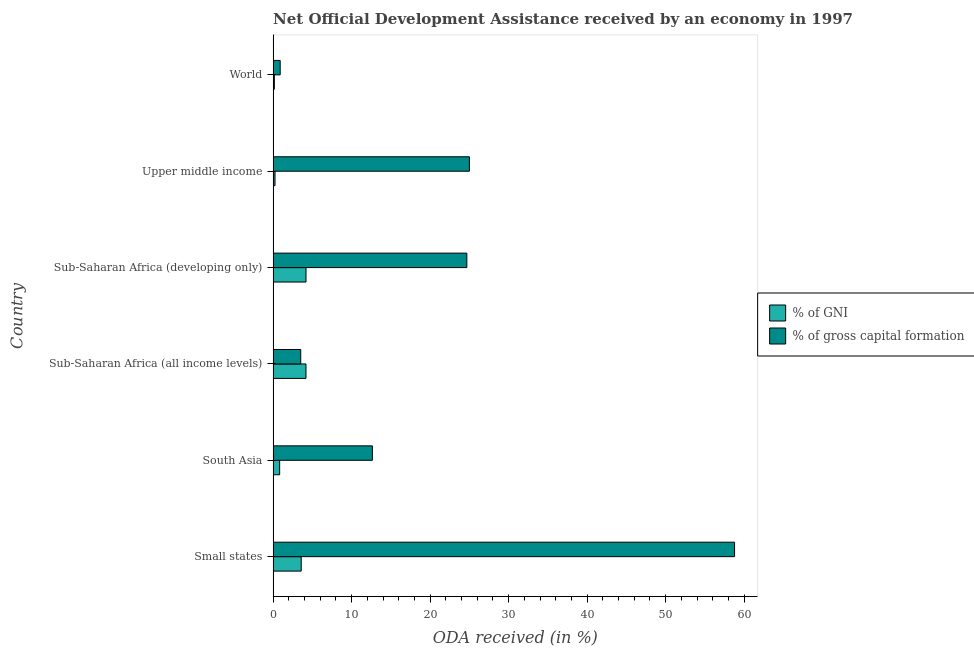How many groups of bars are there?
Offer a very short reply. 6. How many bars are there on the 1st tick from the top?
Your answer should be compact. 2. How many bars are there on the 5th tick from the bottom?
Offer a terse response. 2. What is the oda received as percentage of gross capital formation in Sub-Saharan Africa (developing only)?
Give a very brief answer. 24.67. Across all countries, what is the maximum oda received as percentage of gni?
Make the answer very short. 4.19. Across all countries, what is the minimum oda received as percentage of gross capital formation?
Provide a succinct answer. 0.9. In which country was the oda received as percentage of gross capital formation maximum?
Your response must be concise. Small states. What is the total oda received as percentage of gross capital formation in the graph?
Provide a short and direct response. 125.51. What is the difference between the oda received as percentage of gni in Small states and that in Sub-Saharan Africa (all income levels)?
Your answer should be very brief. -0.6. What is the difference between the oda received as percentage of gross capital formation in South Asia and the oda received as percentage of gni in Sub-Saharan Africa (developing only)?
Give a very brief answer. 8.46. What is the average oda received as percentage of gross capital formation per country?
Ensure brevity in your answer.  20.92. What is the difference between the oda received as percentage of gross capital formation and oda received as percentage of gni in South Asia?
Provide a short and direct response. 11.81. In how many countries, is the oda received as percentage of gross capital formation greater than 40 %?
Keep it short and to the point. 1. What is the ratio of the oda received as percentage of gni in Sub-Saharan Africa (all income levels) to that in Upper middle income?
Ensure brevity in your answer.  17.27. What is the difference between the highest and the second highest oda received as percentage of gross capital formation?
Keep it short and to the point. 33.78. What is the difference between the highest and the lowest oda received as percentage of gross capital formation?
Your answer should be compact. 57.88. In how many countries, is the oda received as percentage of gni greater than the average oda received as percentage of gni taken over all countries?
Provide a short and direct response. 3. Is the sum of the oda received as percentage of gross capital formation in Small states and Upper middle income greater than the maximum oda received as percentage of gni across all countries?
Offer a terse response. Yes. What does the 1st bar from the top in South Asia represents?
Your answer should be very brief. % of gross capital formation. What does the 1st bar from the bottom in Small states represents?
Your answer should be compact. % of GNI. How many bars are there?
Offer a terse response. 12. Are all the bars in the graph horizontal?
Ensure brevity in your answer.  Yes. What is the difference between two consecutive major ticks on the X-axis?
Make the answer very short. 10. Does the graph contain any zero values?
Give a very brief answer. No. Does the graph contain grids?
Your answer should be very brief. No. What is the title of the graph?
Make the answer very short. Net Official Development Assistance received by an economy in 1997. What is the label or title of the X-axis?
Offer a very short reply. ODA received (in %). What is the label or title of the Y-axis?
Keep it short and to the point. Country. What is the ODA received (in %) of % of GNI in Small states?
Offer a terse response. 3.58. What is the ODA received (in %) in % of gross capital formation in Small states?
Offer a terse response. 58.78. What is the ODA received (in %) of % of GNI in South Asia?
Provide a short and direct response. 0.83. What is the ODA received (in %) of % of gross capital formation in South Asia?
Your answer should be very brief. 12.64. What is the ODA received (in %) of % of GNI in Sub-Saharan Africa (all income levels)?
Provide a short and direct response. 4.18. What is the ODA received (in %) of % of gross capital formation in Sub-Saharan Africa (all income levels)?
Give a very brief answer. 3.52. What is the ODA received (in %) in % of GNI in Sub-Saharan Africa (developing only)?
Keep it short and to the point. 4.19. What is the ODA received (in %) of % of gross capital formation in Sub-Saharan Africa (developing only)?
Provide a succinct answer. 24.67. What is the ODA received (in %) in % of GNI in Upper middle income?
Offer a very short reply. 0.24. What is the ODA received (in %) of % of gross capital formation in Upper middle income?
Ensure brevity in your answer.  25. What is the ODA received (in %) in % of GNI in World?
Your answer should be very brief. 0.16. What is the ODA received (in %) of % of gross capital formation in World?
Keep it short and to the point. 0.9. Across all countries, what is the maximum ODA received (in %) in % of GNI?
Make the answer very short. 4.19. Across all countries, what is the maximum ODA received (in %) in % of gross capital formation?
Offer a very short reply. 58.78. Across all countries, what is the minimum ODA received (in %) of % of GNI?
Your answer should be compact. 0.16. Across all countries, what is the minimum ODA received (in %) in % of gross capital formation?
Your answer should be compact. 0.9. What is the total ODA received (in %) of % of GNI in the graph?
Ensure brevity in your answer.  13.18. What is the total ODA received (in %) in % of gross capital formation in the graph?
Ensure brevity in your answer.  125.52. What is the difference between the ODA received (in %) in % of GNI in Small states and that in South Asia?
Ensure brevity in your answer.  2.75. What is the difference between the ODA received (in %) in % of gross capital formation in Small states and that in South Asia?
Your response must be concise. 46.13. What is the difference between the ODA received (in %) of % of GNI in Small states and that in Sub-Saharan Africa (all income levels)?
Offer a very short reply. -0.6. What is the difference between the ODA received (in %) of % of gross capital formation in Small states and that in Sub-Saharan Africa (all income levels)?
Provide a succinct answer. 55.26. What is the difference between the ODA received (in %) in % of GNI in Small states and that in Sub-Saharan Africa (developing only)?
Offer a terse response. -0.61. What is the difference between the ODA received (in %) of % of gross capital formation in Small states and that in Sub-Saharan Africa (developing only)?
Offer a very short reply. 34.1. What is the difference between the ODA received (in %) of % of GNI in Small states and that in Upper middle income?
Provide a short and direct response. 3.34. What is the difference between the ODA received (in %) in % of gross capital formation in Small states and that in Upper middle income?
Make the answer very short. 33.78. What is the difference between the ODA received (in %) of % of GNI in Small states and that in World?
Your response must be concise. 3.42. What is the difference between the ODA received (in %) of % of gross capital formation in Small states and that in World?
Offer a very short reply. 57.88. What is the difference between the ODA received (in %) in % of GNI in South Asia and that in Sub-Saharan Africa (all income levels)?
Your response must be concise. -3.35. What is the difference between the ODA received (in %) of % of gross capital formation in South Asia and that in Sub-Saharan Africa (all income levels)?
Make the answer very short. 9.13. What is the difference between the ODA received (in %) of % of GNI in South Asia and that in Sub-Saharan Africa (developing only)?
Give a very brief answer. -3.36. What is the difference between the ODA received (in %) of % of gross capital formation in South Asia and that in Sub-Saharan Africa (developing only)?
Your response must be concise. -12.03. What is the difference between the ODA received (in %) in % of GNI in South Asia and that in Upper middle income?
Give a very brief answer. 0.59. What is the difference between the ODA received (in %) in % of gross capital formation in South Asia and that in Upper middle income?
Offer a terse response. -12.36. What is the difference between the ODA received (in %) of % of GNI in South Asia and that in World?
Keep it short and to the point. 0.67. What is the difference between the ODA received (in %) of % of gross capital formation in South Asia and that in World?
Your answer should be very brief. 11.74. What is the difference between the ODA received (in %) of % of GNI in Sub-Saharan Africa (all income levels) and that in Sub-Saharan Africa (developing only)?
Provide a short and direct response. -0. What is the difference between the ODA received (in %) of % of gross capital formation in Sub-Saharan Africa (all income levels) and that in Sub-Saharan Africa (developing only)?
Your response must be concise. -21.16. What is the difference between the ODA received (in %) of % of GNI in Sub-Saharan Africa (all income levels) and that in Upper middle income?
Make the answer very short. 3.94. What is the difference between the ODA received (in %) of % of gross capital formation in Sub-Saharan Africa (all income levels) and that in Upper middle income?
Provide a succinct answer. -21.49. What is the difference between the ODA received (in %) of % of GNI in Sub-Saharan Africa (all income levels) and that in World?
Your response must be concise. 4.03. What is the difference between the ODA received (in %) of % of gross capital formation in Sub-Saharan Africa (all income levels) and that in World?
Your response must be concise. 2.62. What is the difference between the ODA received (in %) in % of GNI in Sub-Saharan Africa (developing only) and that in Upper middle income?
Your answer should be very brief. 3.95. What is the difference between the ODA received (in %) of % of gross capital formation in Sub-Saharan Africa (developing only) and that in Upper middle income?
Offer a terse response. -0.33. What is the difference between the ODA received (in %) of % of GNI in Sub-Saharan Africa (developing only) and that in World?
Offer a very short reply. 4.03. What is the difference between the ODA received (in %) in % of gross capital formation in Sub-Saharan Africa (developing only) and that in World?
Provide a short and direct response. 23.77. What is the difference between the ODA received (in %) in % of GNI in Upper middle income and that in World?
Provide a short and direct response. 0.09. What is the difference between the ODA received (in %) in % of gross capital formation in Upper middle income and that in World?
Your answer should be compact. 24.1. What is the difference between the ODA received (in %) of % of GNI in Small states and the ODA received (in %) of % of gross capital formation in South Asia?
Your response must be concise. -9.06. What is the difference between the ODA received (in %) of % of GNI in Small states and the ODA received (in %) of % of gross capital formation in Sub-Saharan Africa (all income levels)?
Offer a very short reply. 0.06. What is the difference between the ODA received (in %) of % of GNI in Small states and the ODA received (in %) of % of gross capital formation in Sub-Saharan Africa (developing only)?
Offer a terse response. -21.09. What is the difference between the ODA received (in %) of % of GNI in Small states and the ODA received (in %) of % of gross capital formation in Upper middle income?
Offer a very short reply. -21.42. What is the difference between the ODA received (in %) of % of GNI in Small states and the ODA received (in %) of % of gross capital formation in World?
Offer a very short reply. 2.68. What is the difference between the ODA received (in %) in % of GNI in South Asia and the ODA received (in %) in % of gross capital formation in Sub-Saharan Africa (all income levels)?
Provide a short and direct response. -2.68. What is the difference between the ODA received (in %) in % of GNI in South Asia and the ODA received (in %) in % of gross capital formation in Sub-Saharan Africa (developing only)?
Offer a very short reply. -23.84. What is the difference between the ODA received (in %) of % of GNI in South Asia and the ODA received (in %) of % of gross capital formation in Upper middle income?
Your response must be concise. -24.17. What is the difference between the ODA received (in %) in % of GNI in South Asia and the ODA received (in %) in % of gross capital formation in World?
Offer a terse response. -0.07. What is the difference between the ODA received (in %) of % of GNI in Sub-Saharan Africa (all income levels) and the ODA received (in %) of % of gross capital formation in Sub-Saharan Africa (developing only)?
Keep it short and to the point. -20.49. What is the difference between the ODA received (in %) in % of GNI in Sub-Saharan Africa (all income levels) and the ODA received (in %) in % of gross capital formation in Upper middle income?
Offer a very short reply. -20.82. What is the difference between the ODA received (in %) in % of GNI in Sub-Saharan Africa (all income levels) and the ODA received (in %) in % of gross capital formation in World?
Provide a short and direct response. 3.28. What is the difference between the ODA received (in %) in % of GNI in Sub-Saharan Africa (developing only) and the ODA received (in %) in % of gross capital formation in Upper middle income?
Your answer should be compact. -20.82. What is the difference between the ODA received (in %) in % of GNI in Sub-Saharan Africa (developing only) and the ODA received (in %) in % of gross capital formation in World?
Your response must be concise. 3.29. What is the difference between the ODA received (in %) of % of GNI in Upper middle income and the ODA received (in %) of % of gross capital formation in World?
Ensure brevity in your answer.  -0.66. What is the average ODA received (in %) in % of GNI per country?
Your answer should be very brief. 2.2. What is the average ODA received (in %) in % of gross capital formation per country?
Your answer should be very brief. 20.92. What is the difference between the ODA received (in %) of % of GNI and ODA received (in %) of % of gross capital formation in Small states?
Your response must be concise. -55.2. What is the difference between the ODA received (in %) in % of GNI and ODA received (in %) in % of gross capital formation in South Asia?
Offer a terse response. -11.81. What is the difference between the ODA received (in %) in % of GNI and ODA received (in %) in % of gross capital formation in Sub-Saharan Africa (all income levels)?
Make the answer very short. 0.67. What is the difference between the ODA received (in %) of % of GNI and ODA received (in %) of % of gross capital formation in Sub-Saharan Africa (developing only)?
Ensure brevity in your answer.  -20.49. What is the difference between the ODA received (in %) in % of GNI and ODA received (in %) in % of gross capital formation in Upper middle income?
Your answer should be compact. -24.76. What is the difference between the ODA received (in %) in % of GNI and ODA received (in %) in % of gross capital formation in World?
Provide a short and direct response. -0.74. What is the ratio of the ODA received (in %) of % of GNI in Small states to that in South Asia?
Provide a short and direct response. 4.3. What is the ratio of the ODA received (in %) of % of gross capital formation in Small states to that in South Asia?
Your response must be concise. 4.65. What is the ratio of the ODA received (in %) of % of GNI in Small states to that in Sub-Saharan Africa (all income levels)?
Offer a terse response. 0.86. What is the ratio of the ODA received (in %) of % of gross capital formation in Small states to that in Sub-Saharan Africa (all income levels)?
Offer a very short reply. 16.71. What is the ratio of the ODA received (in %) in % of GNI in Small states to that in Sub-Saharan Africa (developing only)?
Make the answer very short. 0.85. What is the ratio of the ODA received (in %) in % of gross capital formation in Small states to that in Sub-Saharan Africa (developing only)?
Your answer should be very brief. 2.38. What is the ratio of the ODA received (in %) of % of GNI in Small states to that in Upper middle income?
Ensure brevity in your answer.  14.78. What is the ratio of the ODA received (in %) in % of gross capital formation in Small states to that in Upper middle income?
Your response must be concise. 2.35. What is the ratio of the ODA received (in %) of % of GNI in Small states to that in World?
Give a very brief answer. 22.77. What is the ratio of the ODA received (in %) of % of gross capital formation in Small states to that in World?
Ensure brevity in your answer.  65.37. What is the ratio of the ODA received (in %) in % of GNI in South Asia to that in Sub-Saharan Africa (all income levels)?
Your answer should be compact. 0.2. What is the ratio of the ODA received (in %) in % of gross capital formation in South Asia to that in Sub-Saharan Africa (all income levels)?
Give a very brief answer. 3.6. What is the ratio of the ODA received (in %) of % of GNI in South Asia to that in Sub-Saharan Africa (developing only)?
Give a very brief answer. 0.2. What is the ratio of the ODA received (in %) in % of gross capital formation in South Asia to that in Sub-Saharan Africa (developing only)?
Provide a short and direct response. 0.51. What is the ratio of the ODA received (in %) in % of GNI in South Asia to that in Upper middle income?
Give a very brief answer. 3.43. What is the ratio of the ODA received (in %) of % of gross capital formation in South Asia to that in Upper middle income?
Keep it short and to the point. 0.51. What is the ratio of the ODA received (in %) of % of GNI in South Asia to that in World?
Keep it short and to the point. 5.29. What is the ratio of the ODA received (in %) in % of gross capital formation in South Asia to that in World?
Your answer should be compact. 14.06. What is the ratio of the ODA received (in %) of % of GNI in Sub-Saharan Africa (all income levels) to that in Sub-Saharan Africa (developing only)?
Your response must be concise. 1. What is the ratio of the ODA received (in %) in % of gross capital formation in Sub-Saharan Africa (all income levels) to that in Sub-Saharan Africa (developing only)?
Offer a very short reply. 0.14. What is the ratio of the ODA received (in %) of % of GNI in Sub-Saharan Africa (all income levels) to that in Upper middle income?
Give a very brief answer. 17.27. What is the ratio of the ODA received (in %) in % of gross capital formation in Sub-Saharan Africa (all income levels) to that in Upper middle income?
Your answer should be very brief. 0.14. What is the ratio of the ODA received (in %) in % of GNI in Sub-Saharan Africa (all income levels) to that in World?
Provide a succinct answer. 26.61. What is the ratio of the ODA received (in %) of % of gross capital formation in Sub-Saharan Africa (all income levels) to that in World?
Provide a succinct answer. 3.91. What is the ratio of the ODA received (in %) of % of GNI in Sub-Saharan Africa (developing only) to that in Upper middle income?
Give a very brief answer. 17.28. What is the ratio of the ODA received (in %) of % of GNI in Sub-Saharan Africa (developing only) to that in World?
Keep it short and to the point. 26.63. What is the ratio of the ODA received (in %) in % of gross capital formation in Sub-Saharan Africa (developing only) to that in World?
Offer a terse response. 27.44. What is the ratio of the ODA received (in %) of % of GNI in Upper middle income to that in World?
Provide a short and direct response. 1.54. What is the ratio of the ODA received (in %) of % of gross capital formation in Upper middle income to that in World?
Provide a short and direct response. 27.8. What is the difference between the highest and the second highest ODA received (in %) in % of GNI?
Your response must be concise. 0. What is the difference between the highest and the second highest ODA received (in %) of % of gross capital formation?
Ensure brevity in your answer.  33.78. What is the difference between the highest and the lowest ODA received (in %) of % of GNI?
Make the answer very short. 4.03. What is the difference between the highest and the lowest ODA received (in %) in % of gross capital formation?
Offer a terse response. 57.88. 